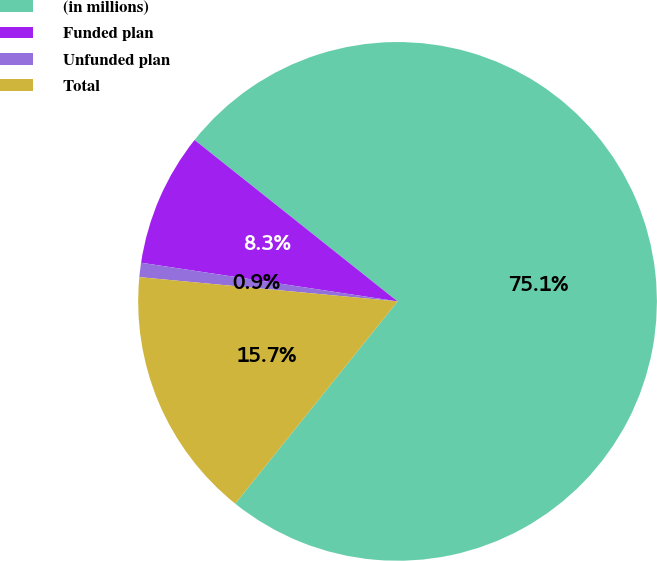Convert chart. <chart><loc_0><loc_0><loc_500><loc_500><pie_chart><fcel>(in millions)<fcel>Funded plan<fcel>Unfunded plan<fcel>Total<nl><fcel>75.07%<fcel>8.31%<fcel>0.89%<fcel>15.73%<nl></chart> 